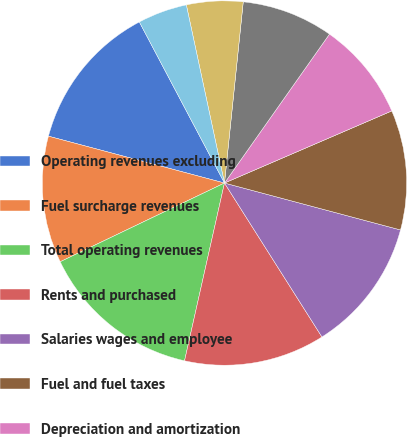<chart> <loc_0><loc_0><loc_500><loc_500><pie_chart><fcel>Operating revenues excluding<fcel>Fuel surcharge revenues<fcel>Total operating revenues<fcel>Rents and purchased<fcel>Salaries wages and employee<fcel>Fuel and fuel taxes<fcel>Depreciation and amortization<fcel>Operating supplies and<fcel>Insurance and claims<fcel>General and administrative<nl><fcel>13.12%<fcel>11.25%<fcel>14.37%<fcel>12.5%<fcel>11.87%<fcel>10.62%<fcel>8.75%<fcel>8.13%<fcel>5.0%<fcel>4.38%<nl></chart> 